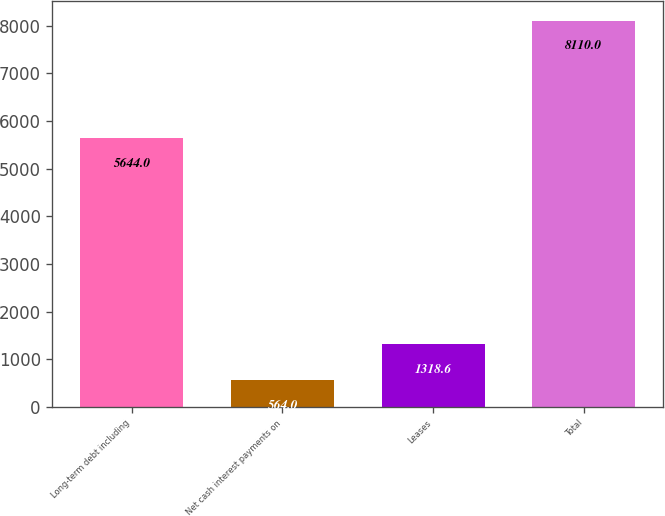Convert chart to OTSL. <chart><loc_0><loc_0><loc_500><loc_500><bar_chart><fcel>Long-term debt including<fcel>Net cash interest payments on<fcel>Leases<fcel>Total<nl><fcel>5644<fcel>564<fcel>1318.6<fcel>8110<nl></chart> 